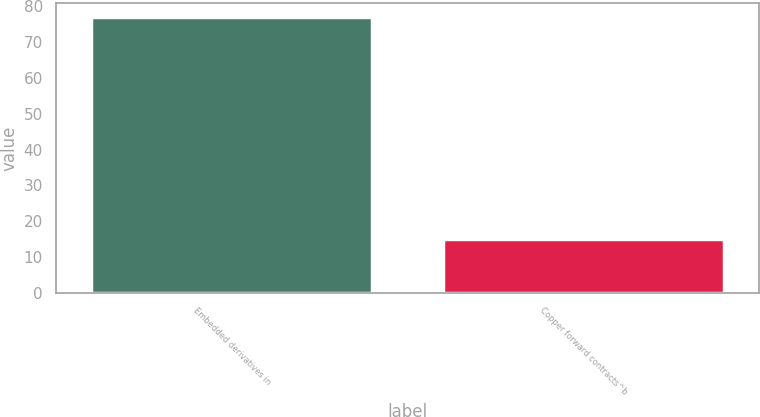Convert chart. <chart><loc_0><loc_0><loc_500><loc_500><bar_chart><fcel>Embedded derivatives in<fcel>Copper forward contracts^b<nl><fcel>77<fcel>15<nl></chart> 